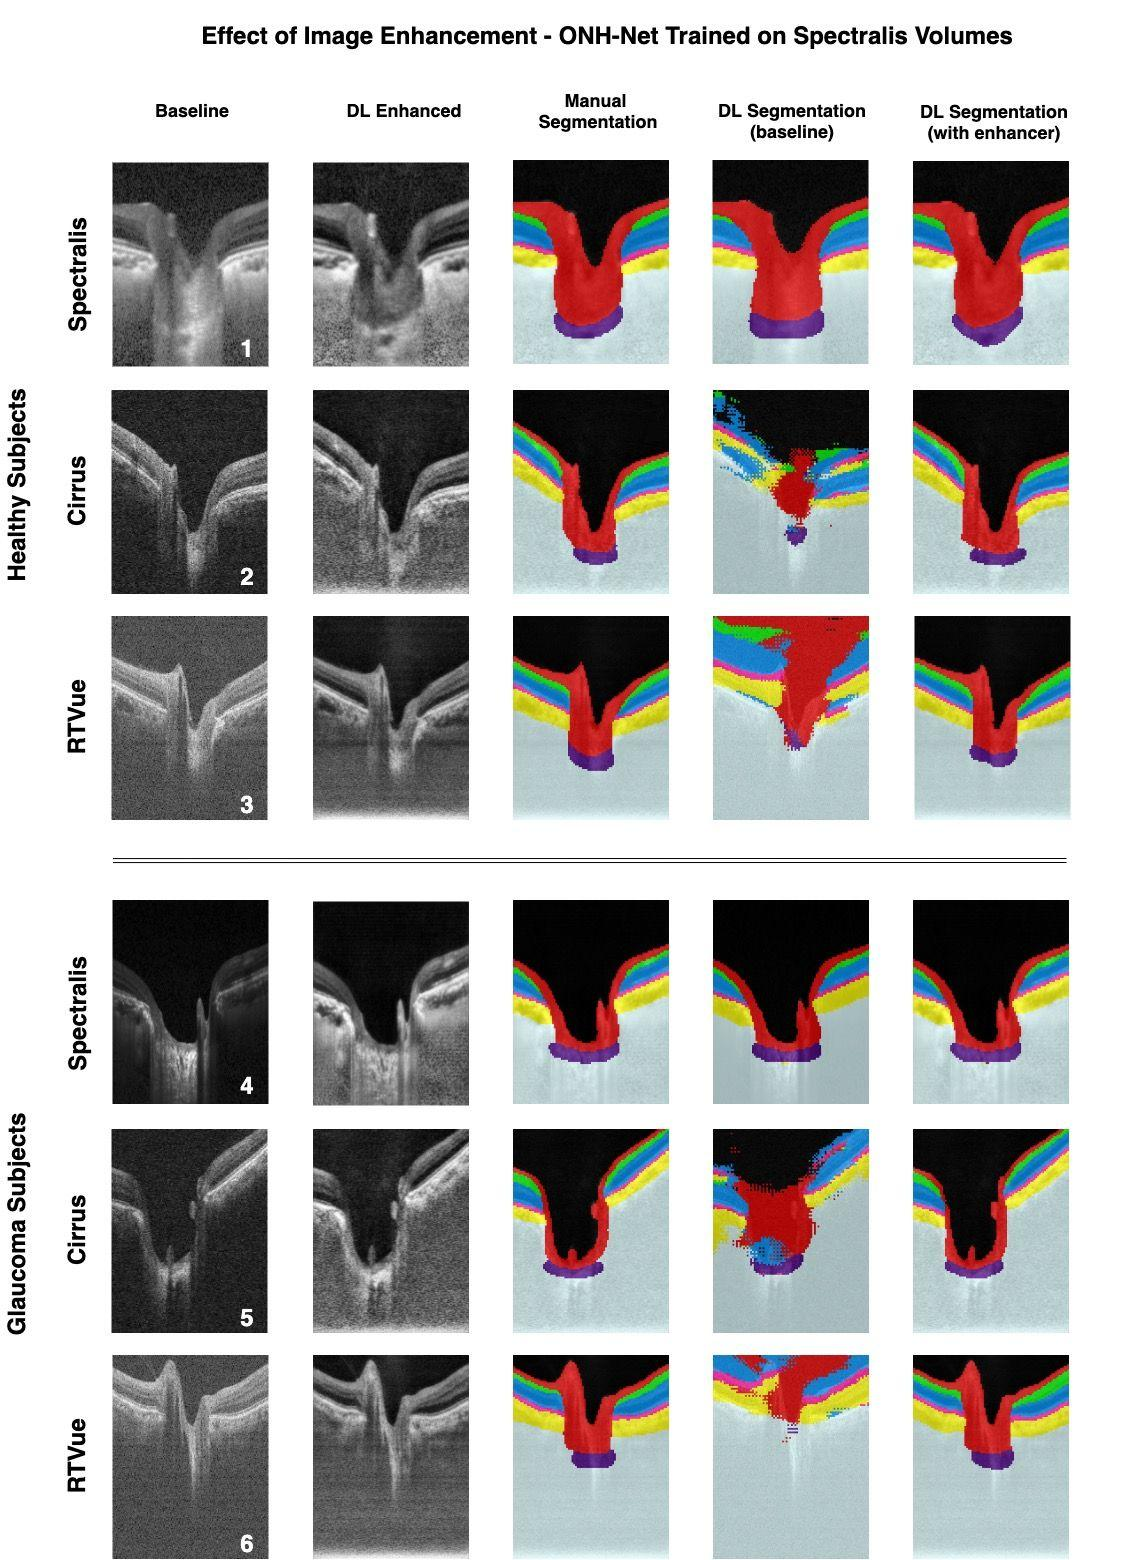Can you explain the differences between the manual and the DL segmentation in the enhanced OCT images? Certainly! In the enhanced OCT images, we observe that the manual segmentation provides a smooth and consistent delineation of the retinal layers, representing a standard ground-truth established by human experts. On the other hand, the DL segmentation, even after enhancement, might show slight inconsistencies or deviations from the manual segmentation due to the algorithm's interpretation of the enhanced image data. These could manifest as variances in layer boundaries or the representation of certain retinal features. 